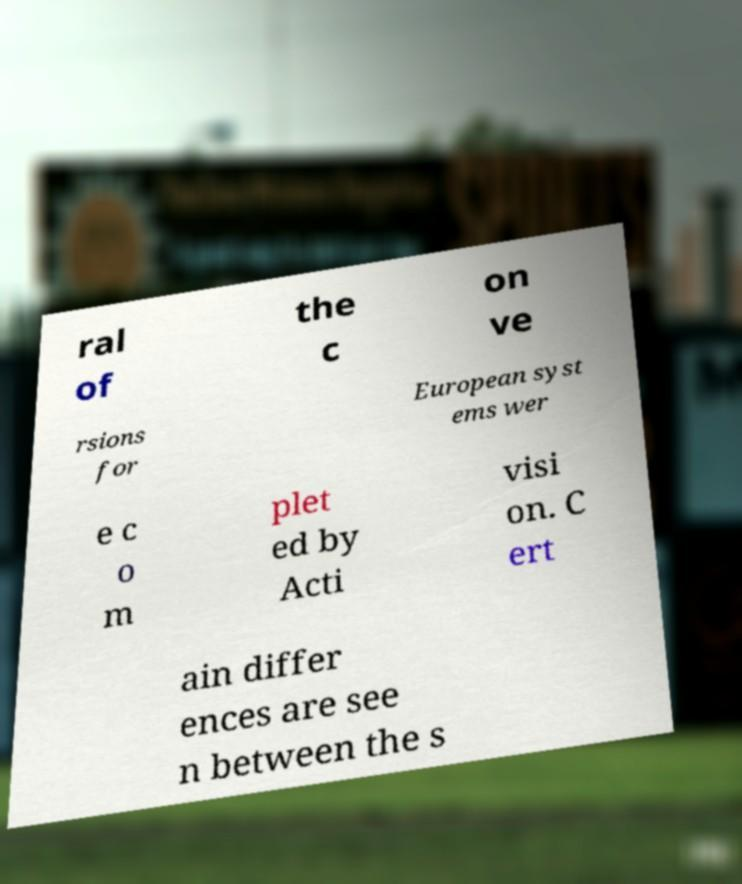For documentation purposes, I need the text within this image transcribed. Could you provide that? ral of the c on ve rsions for European syst ems wer e c o m plet ed by Acti visi on. C ert ain differ ences are see n between the s 